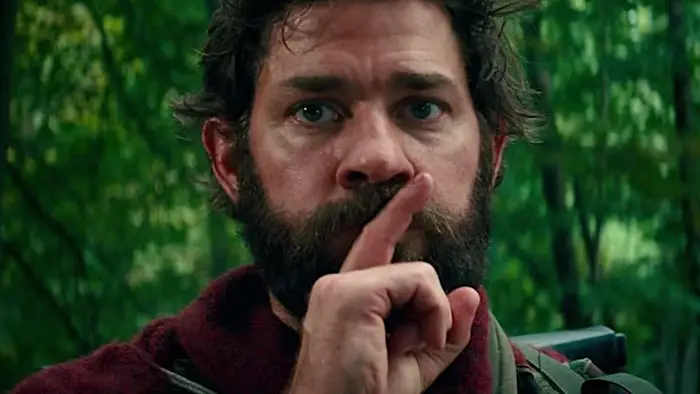What do you see happening in this image? In the image, we see an actor captured in a close-up shot, with his finger pressed to his lips in a universal gesture for silence. His facial expression is serious, reflecting an intense moment. He sports a beard and is dressed in a red jacket, which stands out against the green forest backdrop. His gaze is directed towards something or someone off-camera, adding an element of intrigue to the scene, suggesting that maintaining silence is crucial, possibly due to an imminent threat or a tense situation. 